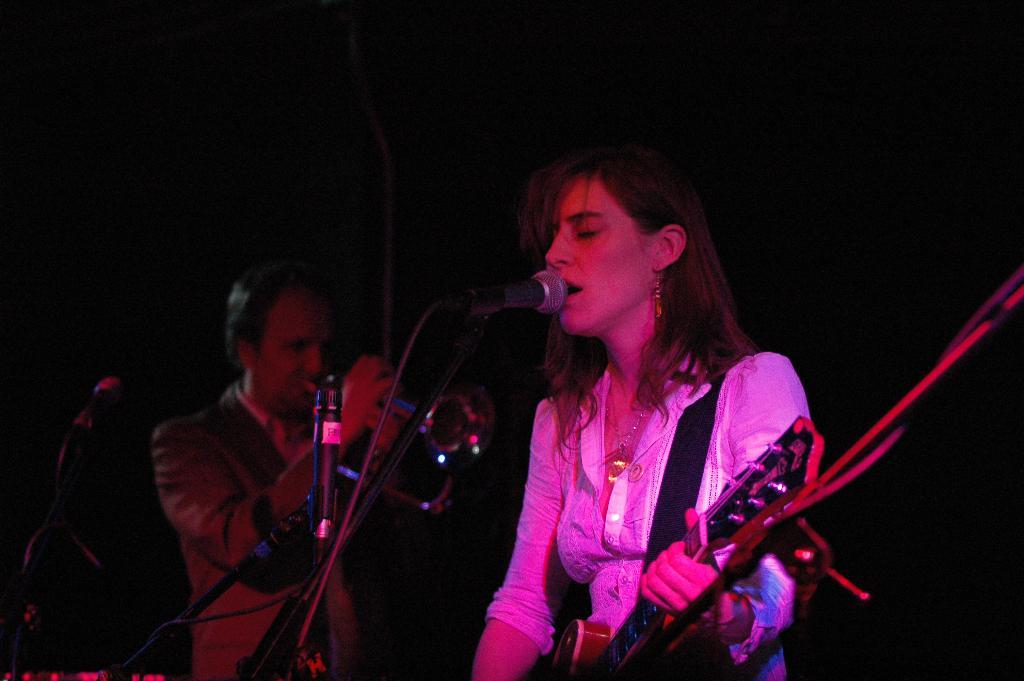How many people are in the image? There are two people in the image. What are the people doing in the image? The two people are playing musical instruments. What object is present in front of the people? There is a microphone in front of the people. What type of lock can be seen on the mint plant in the image? There is no lock or mint plant present in the image; it features two people playing musical instruments with a microphone in front of them. 